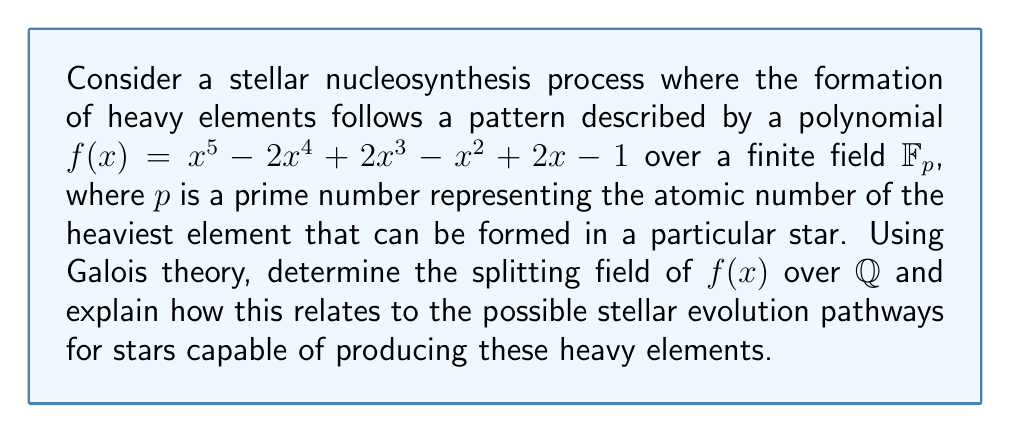Provide a solution to this math problem. To solve this problem, we'll follow these steps:

1) First, we need to determine if the polynomial $f(x)$ is irreducible over $\mathbb{Q}$. We can use Eisenstein's criterion with prime $p=2$:
   
   $2 | -2, 2, -1, 2, -1$
   $2^2 \nmid -1$

   Therefore, $f(x)$ is irreducible over $\mathbb{Q}$.

2) Since $f(x)$ is irreducible and of degree 5, its Galois group over $\mathbb{Q}$ is a transitive subgroup of $S_5$.

3) To determine the exact Galois group, we need to factor $f(x)$ modulo small primes:

   mod 2: $f(x) \equiv x^5 + 1 \equiv (x+1)(x^4+x^3+x^2+x+1)$
   mod 3: $f(x) \equiv x^5 + x^3 + 2x + 2 \equiv (x^2+x+2)(x^3+2x^2+x+1)$
   mod 5: $f(x) \equiv x^5 + 3x^4 + 2x^3 + 4x^2 + 2x + 4 \equiv (x+2)(x^4+x^3+3x^2+3x+2)$

4) From these factorizations, we can deduce that the Galois group has elements of order 2, 3, and 4. The only transitive subgroup of $S_5$ with these properties is $S_5$ itself.

5) Therefore, the Galois group of $f(x)$ over $\mathbb{Q}$ is $S_5$, and the splitting field is an extension of degree 120 over $\mathbb{Q}$.

6) In the context of stellar evolution, this result suggests that there are 120 possible evolutionary pathways for stars capable of producing these heavy elements. Each pathway corresponds to a different arrangement of the roots of $f(x)$, which represent different possible sequences of element formation.

7) The fact that the Galois group is $S_5$ indicates that all possible permutations of these pathways are achievable, suggesting a high degree of variability in stellar nucleosynthesis processes.

8) The prime $p$ in $\mathbb{F}_p$ represents the atomic number of the heaviest element that can be formed. Different values of $p$ would lead to different possible pathways, reflecting how stars of different masses and compositions can produce different sets of heavy elements.
Answer: The splitting field of $f(x)$ over $\mathbb{Q}$ is an extension of degree 120, with Galois group $S_5$. This suggests 120 possible stellar evolution pathways for stars capable of producing the heavy elements described by $f(x)$, with all permutations of these pathways being theoretically achievable. 